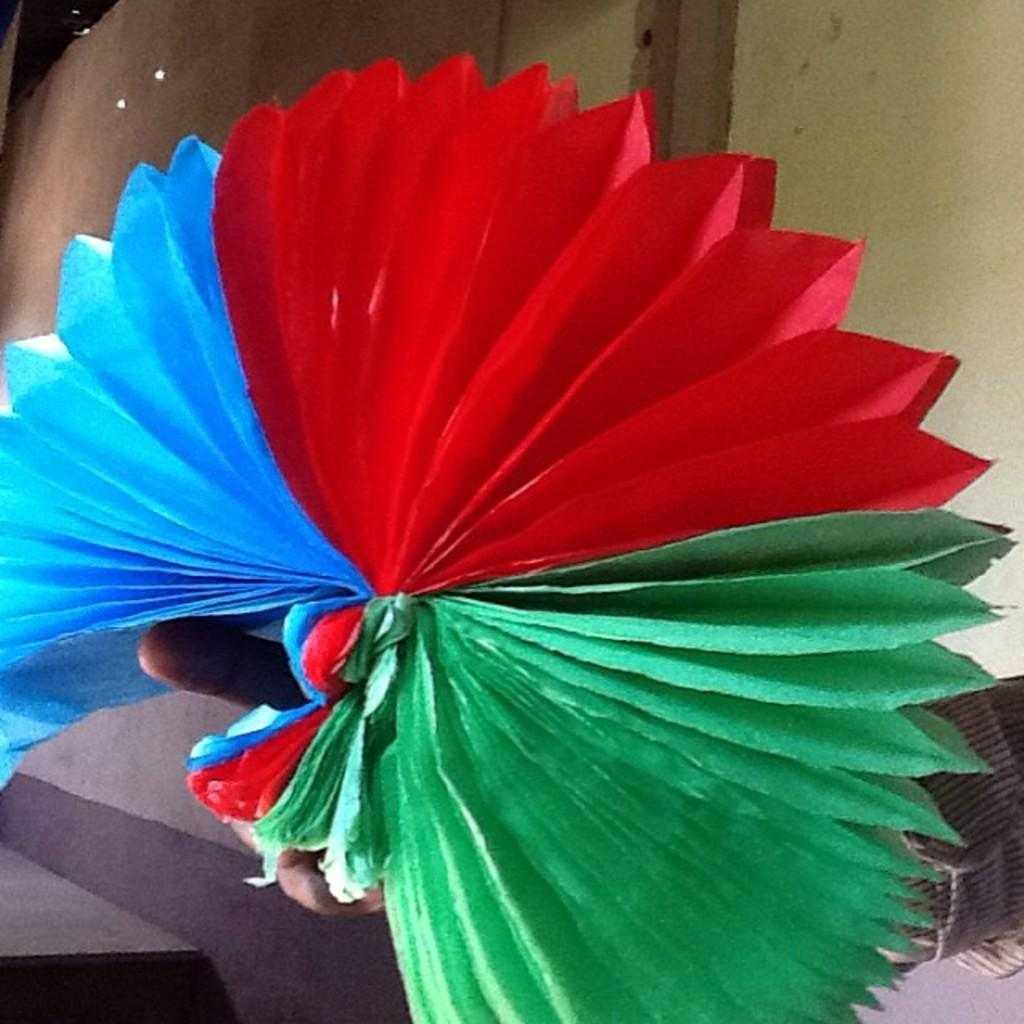What can be seen in the image? There is a person's hand in the image. What is the hand doing? The hand is holding an object. Can you describe the object being held by the hand? The object appears to be a paper art. What type of kite is being flown by the person's mind in the image? There is no kite or person's mind present in the image; it only shows a hand holding a paper art. 